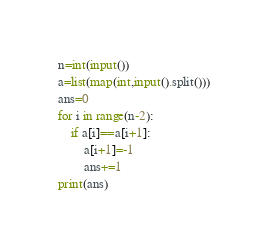Convert code to text. <code><loc_0><loc_0><loc_500><loc_500><_Python_>n=int(input())
a=list(map(int,input().split()))
ans=0
for i in range(n-2):
    if a[i]==a[i+1]:
        a[i+1]=-1
        ans+=1
print(ans)</code> 